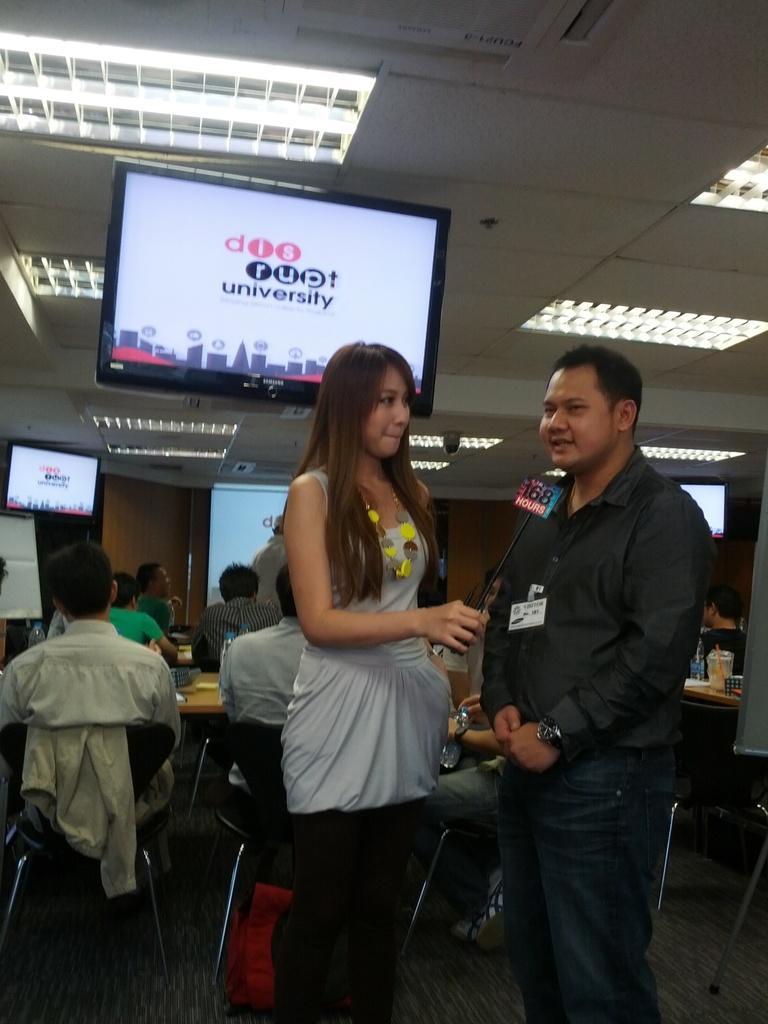How would you summarize this image in a sentence or two? In front of the image there is a man and a woman standing, the woman is holding a mic, behind them there are a few other people sitting on chairs. In front of them on the tables there are some objects and there is a bag on the surface. In the background of the image there is a screen. At the top of the image there are monitors and lights, beside the screen there is a board, behind the person there is a board. 